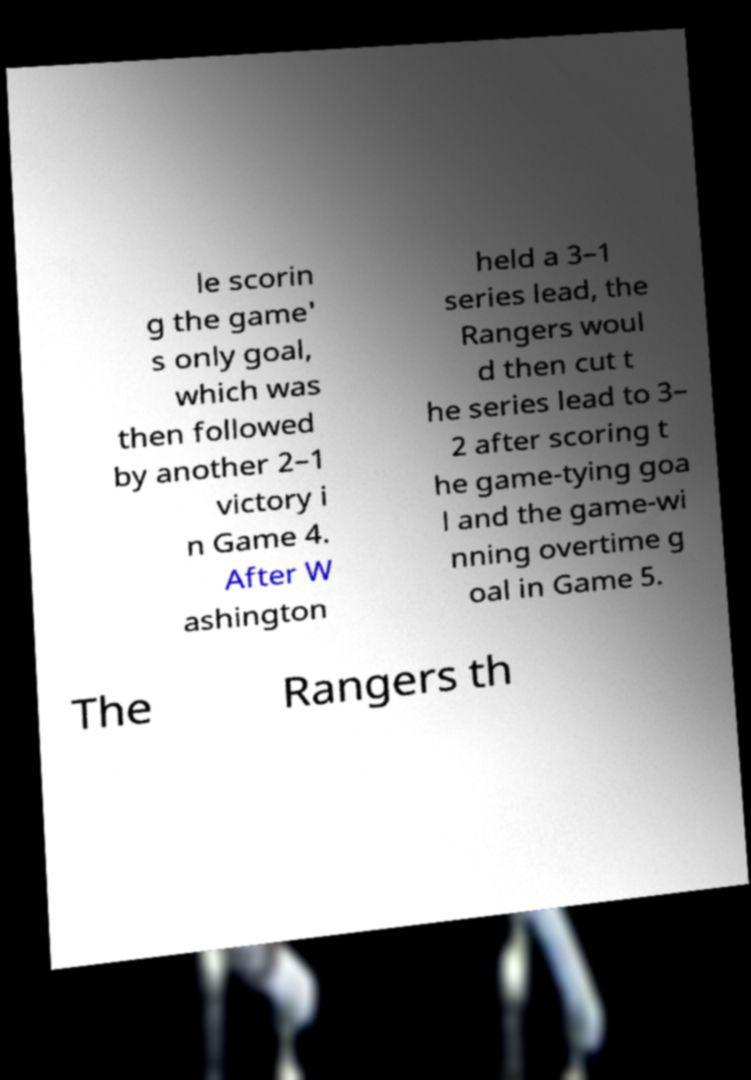Could you extract and type out the text from this image? le scorin g the game' s only goal, which was then followed by another 2–1 victory i n Game 4. After W ashington held a 3–1 series lead, the Rangers woul d then cut t he series lead to 3– 2 after scoring t he game-tying goa l and the game-wi nning overtime g oal in Game 5. The Rangers th 